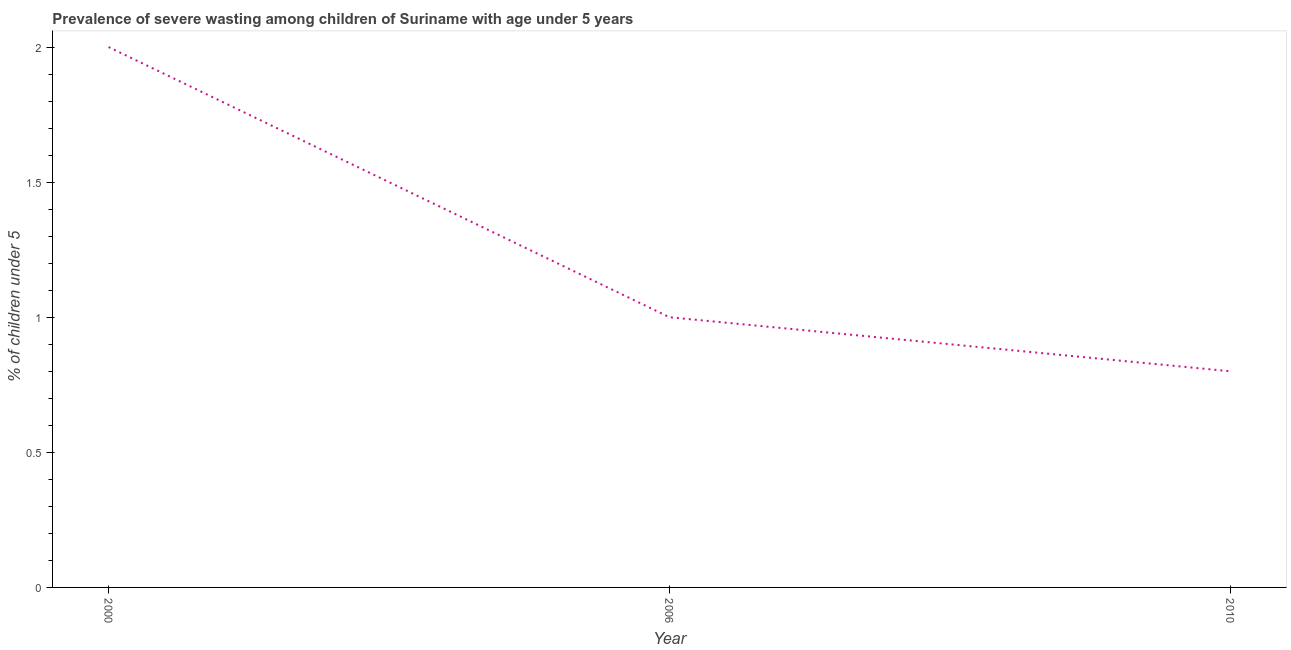Across all years, what is the maximum prevalence of severe wasting?
Offer a very short reply. 2. Across all years, what is the minimum prevalence of severe wasting?
Provide a short and direct response. 0.8. In which year was the prevalence of severe wasting minimum?
Offer a very short reply. 2010. What is the sum of the prevalence of severe wasting?
Provide a short and direct response. 3.8. What is the difference between the prevalence of severe wasting in 2000 and 2010?
Offer a very short reply. 1.2. What is the average prevalence of severe wasting per year?
Keep it short and to the point. 1.27. What is the median prevalence of severe wasting?
Offer a terse response. 1. In how many years, is the prevalence of severe wasting greater than 0.2 %?
Your answer should be very brief. 3. What is the ratio of the prevalence of severe wasting in 2000 to that in 2010?
Provide a short and direct response. 2.5. Is the prevalence of severe wasting in 2006 less than that in 2010?
Keep it short and to the point. No. Is the sum of the prevalence of severe wasting in 2006 and 2010 greater than the maximum prevalence of severe wasting across all years?
Offer a very short reply. No. What is the difference between the highest and the lowest prevalence of severe wasting?
Provide a short and direct response. 1.2. Does the prevalence of severe wasting monotonically increase over the years?
Your answer should be very brief. No. How many lines are there?
Your response must be concise. 1. Does the graph contain any zero values?
Offer a very short reply. No. What is the title of the graph?
Ensure brevity in your answer.  Prevalence of severe wasting among children of Suriname with age under 5 years. What is the label or title of the Y-axis?
Provide a succinct answer.  % of children under 5. What is the  % of children under 5 of 2000?
Offer a very short reply. 2. What is the  % of children under 5 of 2006?
Make the answer very short. 1. What is the  % of children under 5 in 2010?
Your response must be concise. 0.8. What is the difference between the  % of children under 5 in 2000 and 2006?
Provide a short and direct response. 1. What is the ratio of the  % of children under 5 in 2006 to that in 2010?
Your answer should be very brief. 1.25. 